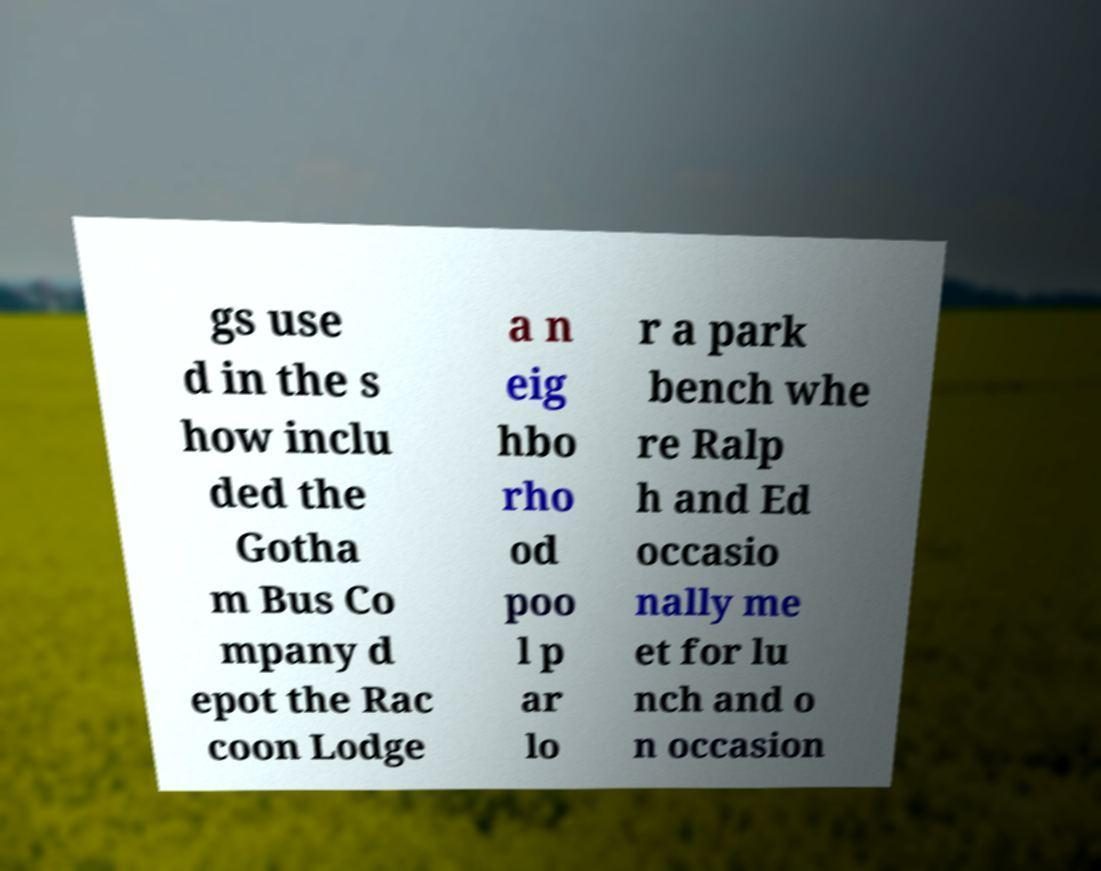I need the written content from this picture converted into text. Can you do that? gs use d in the s how inclu ded the Gotha m Bus Co mpany d epot the Rac coon Lodge a n eig hbo rho od poo l p ar lo r a park bench whe re Ralp h and Ed occasio nally me et for lu nch and o n occasion 